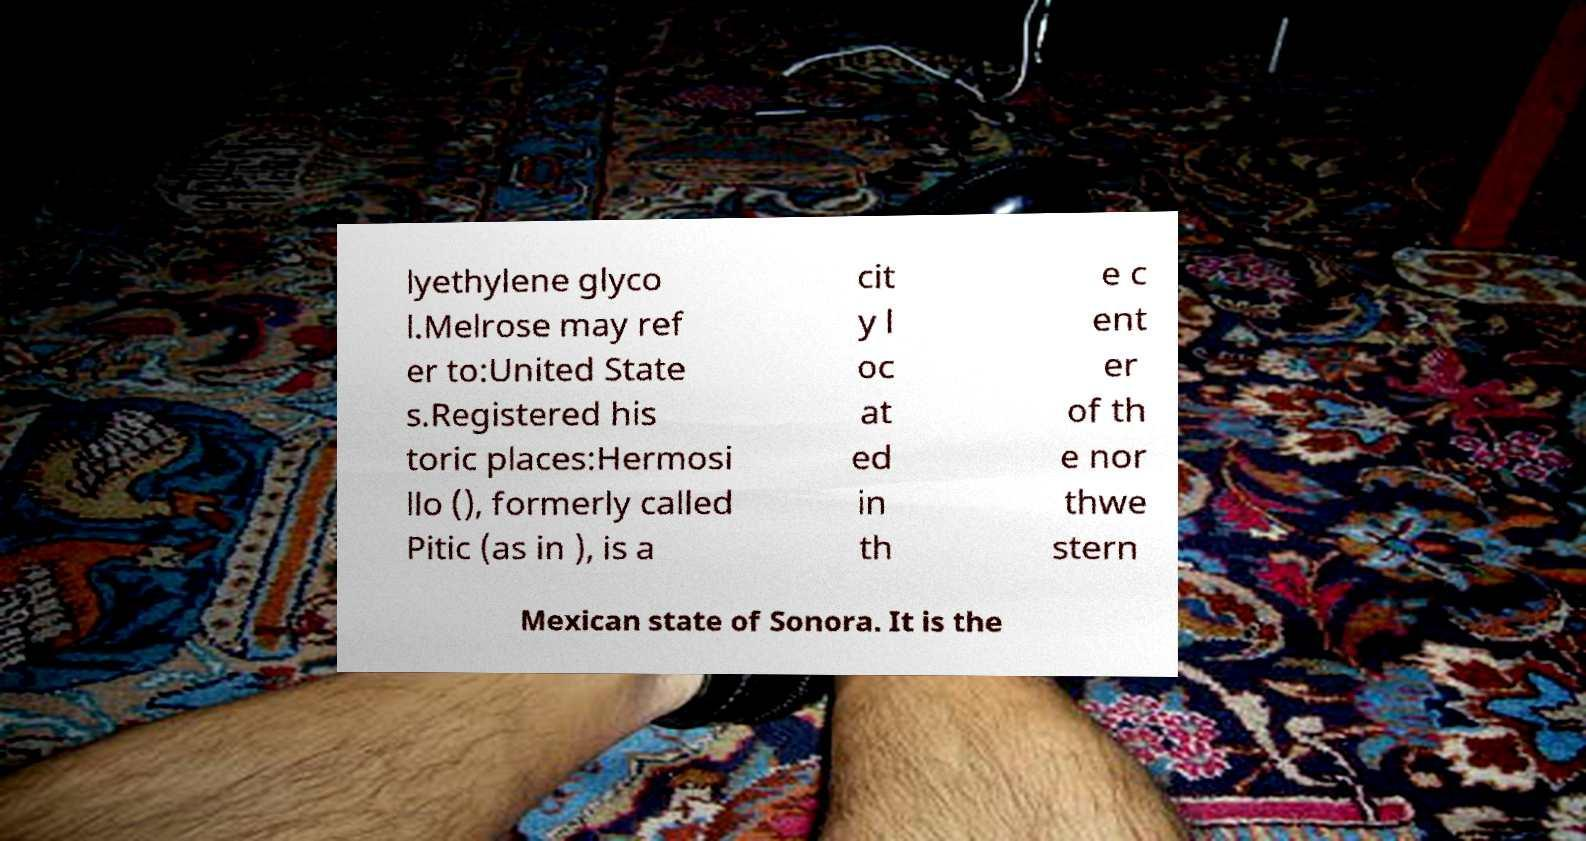There's text embedded in this image that I need extracted. Can you transcribe it verbatim? lyethylene glyco l.Melrose may ref er to:United State s.Registered his toric places:Hermosi llo (), formerly called Pitic (as in ), is a cit y l oc at ed in th e c ent er of th e nor thwe stern Mexican state of Sonora. It is the 